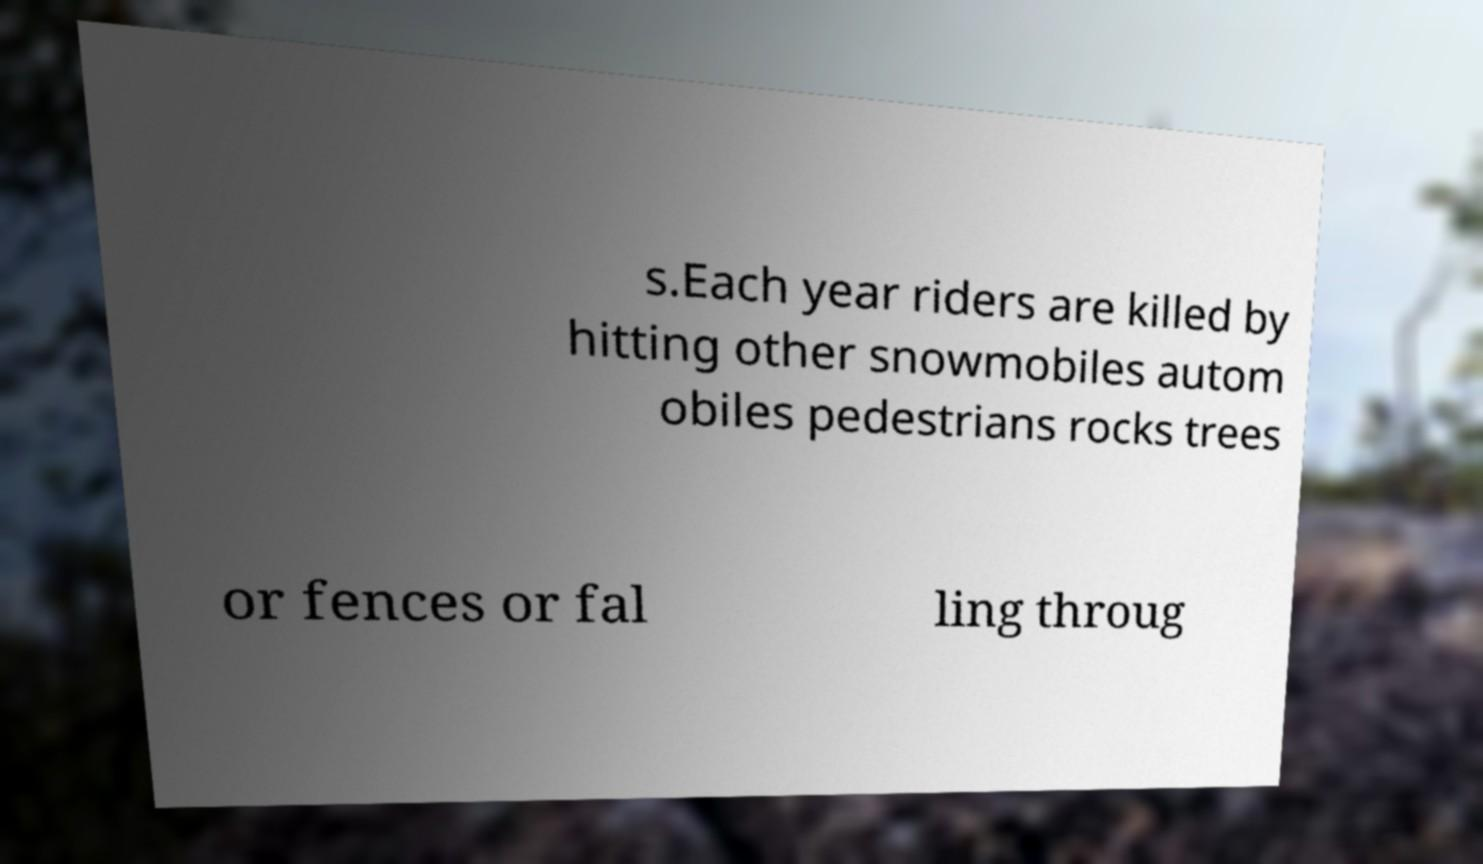What messages or text are displayed in this image? I need them in a readable, typed format. s.Each year riders are killed by hitting other snowmobiles autom obiles pedestrians rocks trees or fences or fal ling throug 